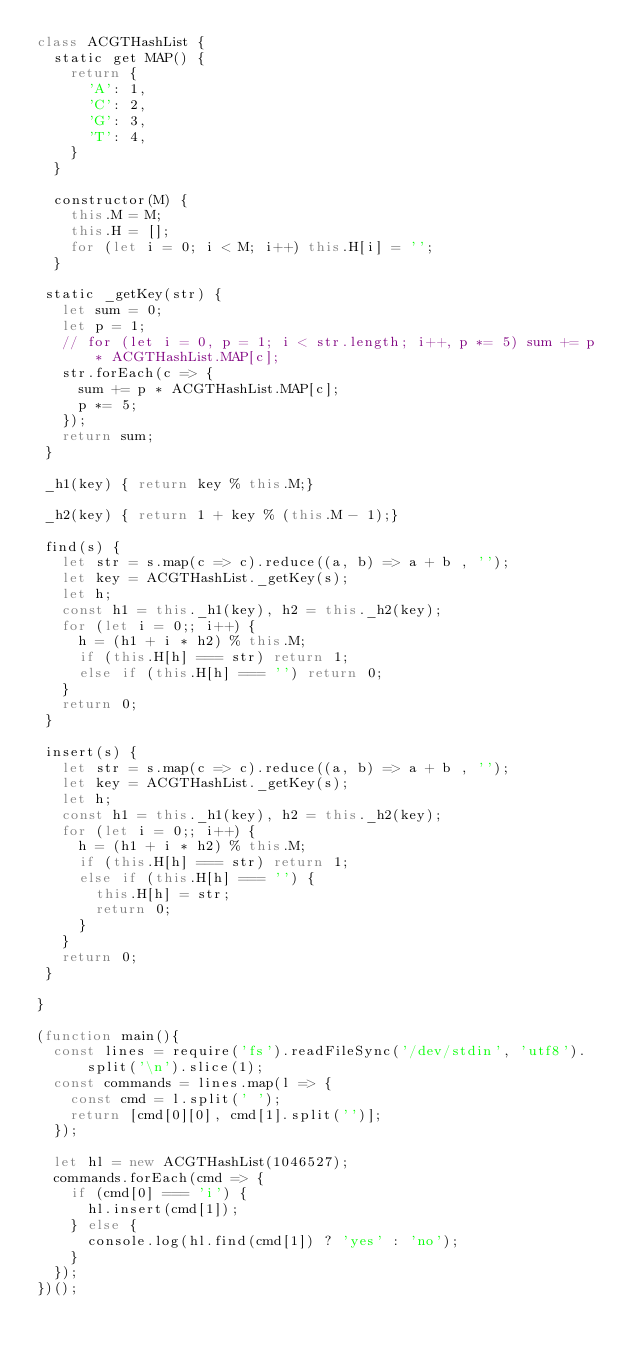Convert code to text. <code><loc_0><loc_0><loc_500><loc_500><_JavaScript_>class ACGTHashList {
  static get MAP() {
    return {
      'A': 1,
      'C': 2,
      'G': 3,
      'T': 4,
    }
  }

  constructor(M) {
    this.M = M;
    this.H = [];
    for (let i = 0; i < M; i++) this.H[i] = '';
  }

 static _getKey(str) {
   let sum = 0;
   let p = 1;
   // for (let i = 0, p = 1; i < str.length; i++, p *= 5) sum += p * ACGTHashList.MAP[c];
   str.forEach(c => {
     sum += p * ACGTHashList.MAP[c];
     p *= 5;
   });
   return sum;
 }

 _h1(key) { return key % this.M;}

 _h2(key) { return 1 + key % (this.M - 1);}

 find(s) {
   let str = s.map(c => c).reduce((a, b) => a + b , '');
   let key = ACGTHashList._getKey(s);
   let h;
   const h1 = this._h1(key), h2 = this._h2(key);
   for (let i = 0;; i++) {
     h = (h1 + i * h2) % this.M;
     if (this.H[h] === str) return 1;
     else if (this.H[h] === '') return 0;
   }
   return 0;
 }

 insert(s) {
   let str = s.map(c => c).reduce((a, b) => a + b , '');
   let key = ACGTHashList._getKey(s);
   let h;
   const h1 = this._h1(key), h2 = this._h2(key);
   for (let i = 0;; i++) {
     h = (h1 + i * h2) % this.M;
     if (this.H[h] === str) return 1;
     else if (this.H[h] === '') {
       this.H[h] = str;
       return 0;
     }
   }
   return 0;
 }

}

(function main(){
  const lines = require('fs').readFileSync('/dev/stdin', 'utf8').split('\n').slice(1);
  const commands = lines.map(l => {
    const cmd = l.split(' ');
    return [cmd[0][0], cmd[1].split('')];
  });
  
  let hl = new ACGTHashList(1046527);
  commands.forEach(cmd => {
    if (cmd[0] === 'i') {
      hl.insert(cmd[1]);
    } else {
      console.log(hl.find(cmd[1]) ? 'yes' : 'no');
    }
  });
})();

</code> 